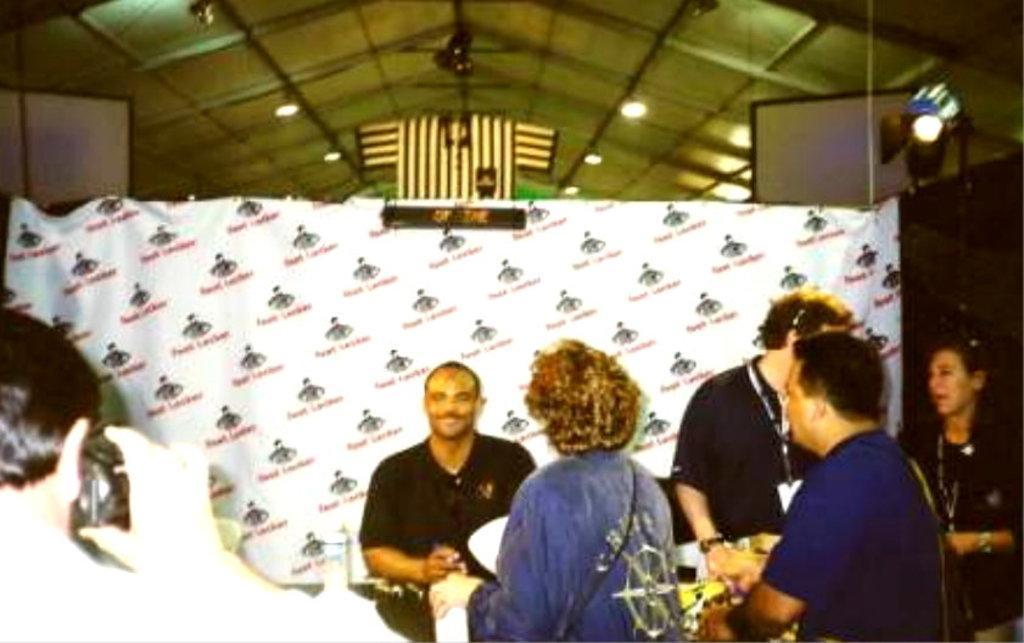In one or two sentences, can you explain what this image depicts? In this picture I can see group of people standing, a person holding a camera, and there is a banner, lights and there are some other objects. 